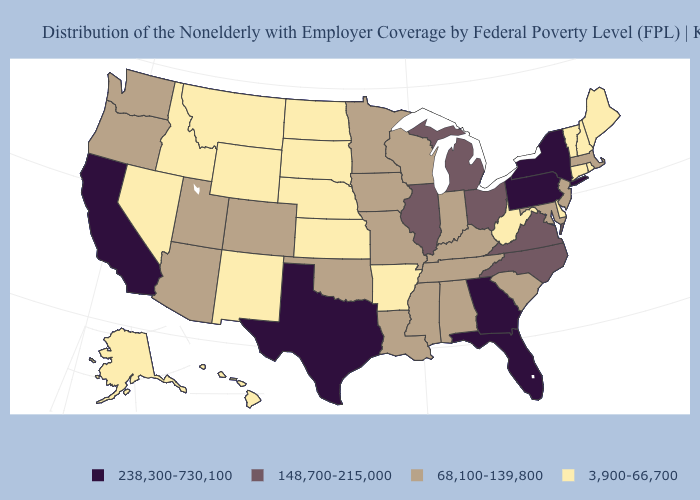Among the states that border New Hampshire , which have the highest value?
Give a very brief answer. Massachusetts. Does Wisconsin have the highest value in the MidWest?
Quick response, please. No. Does the first symbol in the legend represent the smallest category?
Write a very short answer. No. Is the legend a continuous bar?
Short answer required. No. What is the value of Connecticut?
Be succinct. 3,900-66,700. Among the states that border Kentucky , does Indiana have the highest value?
Answer briefly. No. Among the states that border Oregon , which have the lowest value?
Keep it brief. Idaho, Nevada. How many symbols are there in the legend?
Give a very brief answer. 4. What is the value of Oklahoma?
Keep it brief. 68,100-139,800. Does the map have missing data?
Short answer required. No. Which states have the lowest value in the MidWest?
Concise answer only. Kansas, Nebraska, North Dakota, South Dakota. What is the lowest value in states that border Virginia?
Write a very short answer. 3,900-66,700. Does the map have missing data?
Short answer required. No. Does the map have missing data?
Concise answer only. No. Does Pennsylvania have the highest value in the Northeast?
Concise answer only. Yes. 